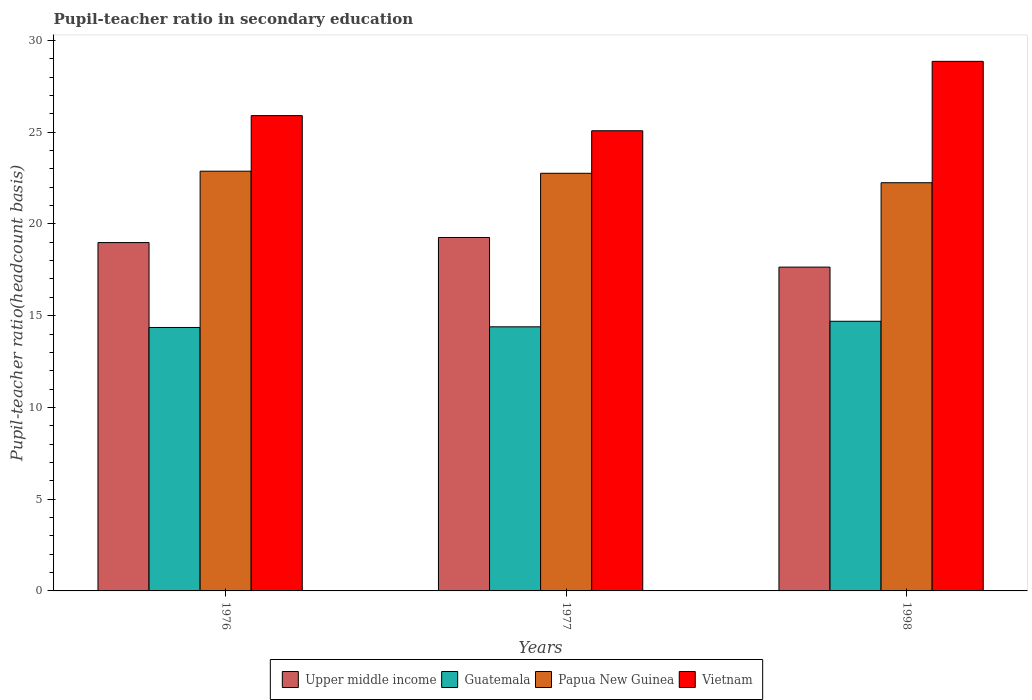How many groups of bars are there?
Provide a short and direct response. 3. Are the number of bars on each tick of the X-axis equal?
Provide a short and direct response. Yes. How many bars are there on the 3rd tick from the right?
Ensure brevity in your answer.  4. What is the label of the 1st group of bars from the left?
Ensure brevity in your answer.  1976. In how many cases, is the number of bars for a given year not equal to the number of legend labels?
Offer a very short reply. 0. What is the pupil-teacher ratio in secondary education in Guatemala in 1977?
Provide a succinct answer. 14.39. Across all years, what is the maximum pupil-teacher ratio in secondary education in Vietnam?
Make the answer very short. 28.86. Across all years, what is the minimum pupil-teacher ratio in secondary education in Vietnam?
Your answer should be very brief. 25.08. In which year was the pupil-teacher ratio in secondary education in Papua New Guinea minimum?
Offer a terse response. 1998. What is the total pupil-teacher ratio in secondary education in Upper middle income in the graph?
Offer a terse response. 55.89. What is the difference between the pupil-teacher ratio in secondary education in Papua New Guinea in 1976 and that in 1977?
Keep it short and to the point. 0.11. What is the difference between the pupil-teacher ratio in secondary education in Vietnam in 1977 and the pupil-teacher ratio in secondary education in Guatemala in 1998?
Offer a very short reply. 10.38. What is the average pupil-teacher ratio in secondary education in Vietnam per year?
Ensure brevity in your answer.  26.61. In the year 1998, what is the difference between the pupil-teacher ratio in secondary education in Upper middle income and pupil-teacher ratio in secondary education in Guatemala?
Offer a very short reply. 2.95. What is the ratio of the pupil-teacher ratio in secondary education in Guatemala in 1976 to that in 1998?
Give a very brief answer. 0.98. What is the difference between the highest and the second highest pupil-teacher ratio in secondary education in Vietnam?
Provide a short and direct response. 2.96. What is the difference between the highest and the lowest pupil-teacher ratio in secondary education in Upper middle income?
Your answer should be very brief. 1.61. In how many years, is the pupil-teacher ratio in secondary education in Papua New Guinea greater than the average pupil-teacher ratio in secondary education in Papua New Guinea taken over all years?
Keep it short and to the point. 2. Is the sum of the pupil-teacher ratio in secondary education in Guatemala in 1977 and 1998 greater than the maximum pupil-teacher ratio in secondary education in Vietnam across all years?
Keep it short and to the point. Yes. Is it the case that in every year, the sum of the pupil-teacher ratio in secondary education in Upper middle income and pupil-teacher ratio in secondary education in Papua New Guinea is greater than the sum of pupil-teacher ratio in secondary education in Guatemala and pupil-teacher ratio in secondary education in Vietnam?
Your answer should be compact. Yes. What does the 4th bar from the left in 1998 represents?
Provide a succinct answer. Vietnam. What does the 3rd bar from the right in 1977 represents?
Offer a terse response. Guatemala. Is it the case that in every year, the sum of the pupil-teacher ratio in secondary education in Papua New Guinea and pupil-teacher ratio in secondary education in Guatemala is greater than the pupil-teacher ratio in secondary education in Upper middle income?
Keep it short and to the point. Yes. How many bars are there?
Make the answer very short. 12. Are all the bars in the graph horizontal?
Ensure brevity in your answer.  No. How many years are there in the graph?
Offer a terse response. 3. What is the title of the graph?
Ensure brevity in your answer.  Pupil-teacher ratio in secondary education. Does "Euro area" appear as one of the legend labels in the graph?
Your answer should be very brief. No. What is the label or title of the Y-axis?
Provide a succinct answer. Pupil-teacher ratio(headcount basis). What is the Pupil-teacher ratio(headcount basis) of Upper middle income in 1976?
Keep it short and to the point. 18.98. What is the Pupil-teacher ratio(headcount basis) in Guatemala in 1976?
Provide a short and direct response. 14.36. What is the Pupil-teacher ratio(headcount basis) of Papua New Guinea in 1976?
Keep it short and to the point. 22.87. What is the Pupil-teacher ratio(headcount basis) of Vietnam in 1976?
Ensure brevity in your answer.  25.9. What is the Pupil-teacher ratio(headcount basis) of Upper middle income in 1977?
Your response must be concise. 19.26. What is the Pupil-teacher ratio(headcount basis) in Guatemala in 1977?
Your response must be concise. 14.39. What is the Pupil-teacher ratio(headcount basis) of Papua New Guinea in 1977?
Offer a very short reply. 22.76. What is the Pupil-teacher ratio(headcount basis) of Vietnam in 1977?
Make the answer very short. 25.08. What is the Pupil-teacher ratio(headcount basis) of Upper middle income in 1998?
Keep it short and to the point. 17.65. What is the Pupil-teacher ratio(headcount basis) of Guatemala in 1998?
Provide a short and direct response. 14.7. What is the Pupil-teacher ratio(headcount basis) in Papua New Guinea in 1998?
Provide a succinct answer. 22.25. What is the Pupil-teacher ratio(headcount basis) in Vietnam in 1998?
Your answer should be very brief. 28.86. Across all years, what is the maximum Pupil-teacher ratio(headcount basis) of Upper middle income?
Make the answer very short. 19.26. Across all years, what is the maximum Pupil-teacher ratio(headcount basis) of Guatemala?
Ensure brevity in your answer.  14.7. Across all years, what is the maximum Pupil-teacher ratio(headcount basis) of Papua New Guinea?
Keep it short and to the point. 22.87. Across all years, what is the maximum Pupil-teacher ratio(headcount basis) in Vietnam?
Make the answer very short. 28.86. Across all years, what is the minimum Pupil-teacher ratio(headcount basis) in Upper middle income?
Provide a short and direct response. 17.65. Across all years, what is the minimum Pupil-teacher ratio(headcount basis) in Guatemala?
Keep it short and to the point. 14.36. Across all years, what is the minimum Pupil-teacher ratio(headcount basis) of Papua New Guinea?
Your response must be concise. 22.25. Across all years, what is the minimum Pupil-teacher ratio(headcount basis) of Vietnam?
Provide a succinct answer. 25.08. What is the total Pupil-teacher ratio(headcount basis) of Upper middle income in the graph?
Make the answer very short. 55.89. What is the total Pupil-teacher ratio(headcount basis) of Guatemala in the graph?
Give a very brief answer. 43.45. What is the total Pupil-teacher ratio(headcount basis) of Papua New Guinea in the graph?
Your response must be concise. 67.88. What is the total Pupil-teacher ratio(headcount basis) in Vietnam in the graph?
Give a very brief answer. 79.84. What is the difference between the Pupil-teacher ratio(headcount basis) of Upper middle income in 1976 and that in 1977?
Provide a succinct answer. -0.28. What is the difference between the Pupil-teacher ratio(headcount basis) in Guatemala in 1976 and that in 1977?
Offer a terse response. -0.04. What is the difference between the Pupil-teacher ratio(headcount basis) of Papua New Guinea in 1976 and that in 1977?
Ensure brevity in your answer.  0.11. What is the difference between the Pupil-teacher ratio(headcount basis) of Vietnam in 1976 and that in 1977?
Offer a very short reply. 0.83. What is the difference between the Pupil-teacher ratio(headcount basis) in Upper middle income in 1976 and that in 1998?
Make the answer very short. 1.34. What is the difference between the Pupil-teacher ratio(headcount basis) of Guatemala in 1976 and that in 1998?
Make the answer very short. -0.34. What is the difference between the Pupil-teacher ratio(headcount basis) of Papua New Guinea in 1976 and that in 1998?
Make the answer very short. 0.63. What is the difference between the Pupil-teacher ratio(headcount basis) of Vietnam in 1976 and that in 1998?
Offer a very short reply. -2.96. What is the difference between the Pupil-teacher ratio(headcount basis) in Upper middle income in 1977 and that in 1998?
Your answer should be very brief. 1.61. What is the difference between the Pupil-teacher ratio(headcount basis) of Guatemala in 1977 and that in 1998?
Offer a terse response. -0.3. What is the difference between the Pupil-teacher ratio(headcount basis) of Papua New Guinea in 1977 and that in 1998?
Give a very brief answer. 0.51. What is the difference between the Pupil-teacher ratio(headcount basis) in Vietnam in 1977 and that in 1998?
Offer a very short reply. -3.78. What is the difference between the Pupil-teacher ratio(headcount basis) of Upper middle income in 1976 and the Pupil-teacher ratio(headcount basis) of Guatemala in 1977?
Your response must be concise. 4.59. What is the difference between the Pupil-teacher ratio(headcount basis) of Upper middle income in 1976 and the Pupil-teacher ratio(headcount basis) of Papua New Guinea in 1977?
Make the answer very short. -3.78. What is the difference between the Pupil-teacher ratio(headcount basis) in Upper middle income in 1976 and the Pupil-teacher ratio(headcount basis) in Vietnam in 1977?
Ensure brevity in your answer.  -6.09. What is the difference between the Pupil-teacher ratio(headcount basis) of Guatemala in 1976 and the Pupil-teacher ratio(headcount basis) of Papua New Guinea in 1977?
Offer a very short reply. -8.4. What is the difference between the Pupil-teacher ratio(headcount basis) of Guatemala in 1976 and the Pupil-teacher ratio(headcount basis) of Vietnam in 1977?
Make the answer very short. -10.72. What is the difference between the Pupil-teacher ratio(headcount basis) in Papua New Guinea in 1976 and the Pupil-teacher ratio(headcount basis) in Vietnam in 1977?
Give a very brief answer. -2.2. What is the difference between the Pupil-teacher ratio(headcount basis) of Upper middle income in 1976 and the Pupil-teacher ratio(headcount basis) of Guatemala in 1998?
Ensure brevity in your answer.  4.29. What is the difference between the Pupil-teacher ratio(headcount basis) of Upper middle income in 1976 and the Pupil-teacher ratio(headcount basis) of Papua New Guinea in 1998?
Your response must be concise. -3.26. What is the difference between the Pupil-teacher ratio(headcount basis) in Upper middle income in 1976 and the Pupil-teacher ratio(headcount basis) in Vietnam in 1998?
Your answer should be very brief. -9.88. What is the difference between the Pupil-teacher ratio(headcount basis) of Guatemala in 1976 and the Pupil-teacher ratio(headcount basis) of Papua New Guinea in 1998?
Offer a terse response. -7.89. What is the difference between the Pupil-teacher ratio(headcount basis) of Guatemala in 1976 and the Pupil-teacher ratio(headcount basis) of Vietnam in 1998?
Give a very brief answer. -14.5. What is the difference between the Pupil-teacher ratio(headcount basis) of Papua New Guinea in 1976 and the Pupil-teacher ratio(headcount basis) of Vietnam in 1998?
Keep it short and to the point. -5.99. What is the difference between the Pupil-teacher ratio(headcount basis) of Upper middle income in 1977 and the Pupil-teacher ratio(headcount basis) of Guatemala in 1998?
Offer a very short reply. 4.57. What is the difference between the Pupil-teacher ratio(headcount basis) in Upper middle income in 1977 and the Pupil-teacher ratio(headcount basis) in Papua New Guinea in 1998?
Provide a short and direct response. -2.98. What is the difference between the Pupil-teacher ratio(headcount basis) in Upper middle income in 1977 and the Pupil-teacher ratio(headcount basis) in Vietnam in 1998?
Provide a short and direct response. -9.6. What is the difference between the Pupil-teacher ratio(headcount basis) in Guatemala in 1977 and the Pupil-teacher ratio(headcount basis) in Papua New Guinea in 1998?
Make the answer very short. -7.85. What is the difference between the Pupil-teacher ratio(headcount basis) in Guatemala in 1977 and the Pupil-teacher ratio(headcount basis) in Vietnam in 1998?
Your answer should be very brief. -14.47. What is the difference between the Pupil-teacher ratio(headcount basis) in Papua New Guinea in 1977 and the Pupil-teacher ratio(headcount basis) in Vietnam in 1998?
Your answer should be compact. -6.1. What is the average Pupil-teacher ratio(headcount basis) in Upper middle income per year?
Ensure brevity in your answer.  18.63. What is the average Pupil-teacher ratio(headcount basis) of Guatemala per year?
Your answer should be very brief. 14.48. What is the average Pupil-teacher ratio(headcount basis) of Papua New Guinea per year?
Offer a terse response. 22.63. What is the average Pupil-teacher ratio(headcount basis) of Vietnam per year?
Your answer should be compact. 26.61. In the year 1976, what is the difference between the Pupil-teacher ratio(headcount basis) in Upper middle income and Pupil-teacher ratio(headcount basis) in Guatemala?
Give a very brief answer. 4.63. In the year 1976, what is the difference between the Pupil-teacher ratio(headcount basis) in Upper middle income and Pupil-teacher ratio(headcount basis) in Papua New Guinea?
Offer a terse response. -3.89. In the year 1976, what is the difference between the Pupil-teacher ratio(headcount basis) of Upper middle income and Pupil-teacher ratio(headcount basis) of Vietnam?
Give a very brief answer. -6.92. In the year 1976, what is the difference between the Pupil-teacher ratio(headcount basis) in Guatemala and Pupil-teacher ratio(headcount basis) in Papua New Guinea?
Keep it short and to the point. -8.52. In the year 1976, what is the difference between the Pupil-teacher ratio(headcount basis) in Guatemala and Pupil-teacher ratio(headcount basis) in Vietnam?
Keep it short and to the point. -11.55. In the year 1976, what is the difference between the Pupil-teacher ratio(headcount basis) of Papua New Guinea and Pupil-teacher ratio(headcount basis) of Vietnam?
Keep it short and to the point. -3.03. In the year 1977, what is the difference between the Pupil-teacher ratio(headcount basis) of Upper middle income and Pupil-teacher ratio(headcount basis) of Guatemala?
Your answer should be very brief. 4.87. In the year 1977, what is the difference between the Pupil-teacher ratio(headcount basis) in Upper middle income and Pupil-teacher ratio(headcount basis) in Papua New Guinea?
Your answer should be compact. -3.5. In the year 1977, what is the difference between the Pupil-teacher ratio(headcount basis) in Upper middle income and Pupil-teacher ratio(headcount basis) in Vietnam?
Your response must be concise. -5.82. In the year 1977, what is the difference between the Pupil-teacher ratio(headcount basis) in Guatemala and Pupil-teacher ratio(headcount basis) in Papua New Guinea?
Keep it short and to the point. -8.37. In the year 1977, what is the difference between the Pupil-teacher ratio(headcount basis) in Guatemala and Pupil-teacher ratio(headcount basis) in Vietnam?
Offer a very short reply. -10.69. In the year 1977, what is the difference between the Pupil-teacher ratio(headcount basis) in Papua New Guinea and Pupil-teacher ratio(headcount basis) in Vietnam?
Ensure brevity in your answer.  -2.32. In the year 1998, what is the difference between the Pupil-teacher ratio(headcount basis) of Upper middle income and Pupil-teacher ratio(headcount basis) of Guatemala?
Your answer should be very brief. 2.95. In the year 1998, what is the difference between the Pupil-teacher ratio(headcount basis) in Upper middle income and Pupil-teacher ratio(headcount basis) in Papua New Guinea?
Provide a short and direct response. -4.6. In the year 1998, what is the difference between the Pupil-teacher ratio(headcount basis) in Upper middle income and Pupil-teacher ratio(headcount basis) in Vietnam?
Offer a terse response. -11.21. In the year 1998, what is the difference between the Pupil-teacher ratio(headcount basis) of Guatemala and Pupil-teacher ratio(headcount basis) of Papua New Guinea?
Your response must be concise. -7.55. In the year 1998, what is the difference between the Pupil-teacher ratio(headcount basis) of Guatemala and Pupil-teacher ratio(headcount basis) of Vietnam?
Your answer should be compact. -14.17. In the year 1998, what is the difference between the Pupil-teacher ratio(headcount basis) in Papua New Guinea and Pupil-teacher ratio(headcount basis) in Vietnam?
Give a very brief answer. -6.61. What is the ratio of the Pupil-teacher ratio(headcount basis) in Upper middle income in 1976 to that in 1977?
Keep it short and to the point. 0.99. What is the ratio of the Pupil-teacher ratio(headcount basis) in Guatemala in 1976 to that in 1977?
Ensure brevity in your answer.  1. What is the ratio of the Pupil-teacher ratio(headcount basis) in Papua New Guinea in 1976 to that in 1977?
Offer a very short reply. 1. What is the ratio of the Pupil-teacher ratio(headcount basis) of Vietnam in 1976 to that in 1977?
Give a very brief answer. 1.03. What is the ratio of the Pupil-teacher ratio(headcount basis) in Upper middle income in 1976 to that in 1998?
Make the answer very short. 1.08. What is the ratio of the Pupil-teacher ratio(headcount basis) of Guatemala in 1976 to that in 1998?
Ensure brevity in your answer.  0.98. What is the ratio of the Pupil-teacher ratio(headcount basis) of Papua New Guinea in 1976 to that in 1998?
Make the answer very short. 1.03. What is the ratio of the Pupil-teacher ratio(headcount basis) of Vietnam in 1976 to that in 1998?
Provide a succinct answer. 0.9. What is the ratio of the Pupil-teacher ratio(headcount basis) of Upper middle income in 1977 to that in 1998?
Offer a very short reply. 1.09. What is the ratio of the Pupil-teacher ratio(headcount basis) of Guatemala in 1977 to that in 1998?
Offer a very short reply. 0.98. What is the ratio of the Pupil-teacher ratio(headcount basis) in Papua New Guinea in 1977 to that in 1998?
Give a very brief answer. 1.02. What is the ratio of the Pupil-teacher ratio(headcount basis) of Vietnam in 1977 to that in 1998?
Offer a terse response. 0.87. What is the difference between the highest and the second highest Pupil-teacher ratio(headcount basis) of Upper middle income?
Offer a very short reply. 0.28. What is the difference between the highest and the second highest Pupil-teacher ratio(headcount basis) of Guatemala?
Provide a succinct answer. 0.3. What is the difference between the highest and the second highest Pupil-teacher ratio(headcount basis) in Papua New Guinea?
Ensure brevity in your answer.  0.11. What is the difference between the highest and the second highest Pupil-teacher ratio(headcount basis) of Vietnam?
Provide a short and direct response. 2.96. What is the difference between the highest and the lowest Pupil-teacher ratio(headcount basis) of Upper middle income?
Provide a succinct answer. 1.61. What is the difference between the highest and the lowest Pupil-teacher ratio(headcount basis) of Guatemala?
Provide a succinct answer. 0.34. What is the difference between the highest and the lowest Pupil-teacher ratio(headcount basis) in Papua New Guinea?
Provide a short and direct response. 0.63. What is the difference between the highest and the lowest Pupil-teacher ratio(headcount basis) in Vietnam?
Offer a very short reply. 3.78. 